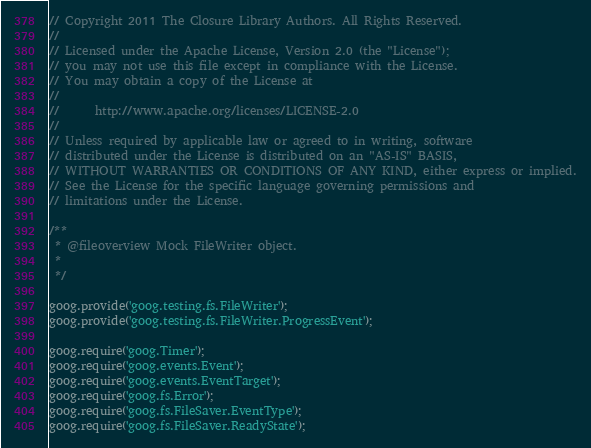<code> <loc_0><loc_0><loc_500><loc_500><_JavaScript_>// Copyright 2011 The Closure Library Authors. All Rights Reserved.
//
// Licensed under the Apache License, Version 2.0 (the "License");
// you may not use this file except in compliance with the License.
// You may obtain a copy of the License at
//
//      http://www.apache.org/licenses/LICENSE-2.0
//
// Unless required by applicable law or agreed to in writing, software
// distributed under the License is distributed on an "AS-IS" BASIS,
// WITHOUT WARRANTIES OR CONDITIONS OF ANY KIND, either express or implied.
// See the License for the specific language governing permissions and
// limitations under the License.

/**
 * @fileoverview Mock FileWriter object.
 *
 */

goog.provide('goog.testing.fs.FileWriter');
goog.provide('goog.testing.fs.FileWriter.ProgressEvent');

goog.require('goog.Timer');
goog.require('goog.events.Event');
goog.require('goog.events.EventTarget');
goog.require('goog.fs.Error');
goog.require('goog.fs.FileSaver.EventType');
goog.require('goog.fs.FileSaver.ReadyState');</code> 